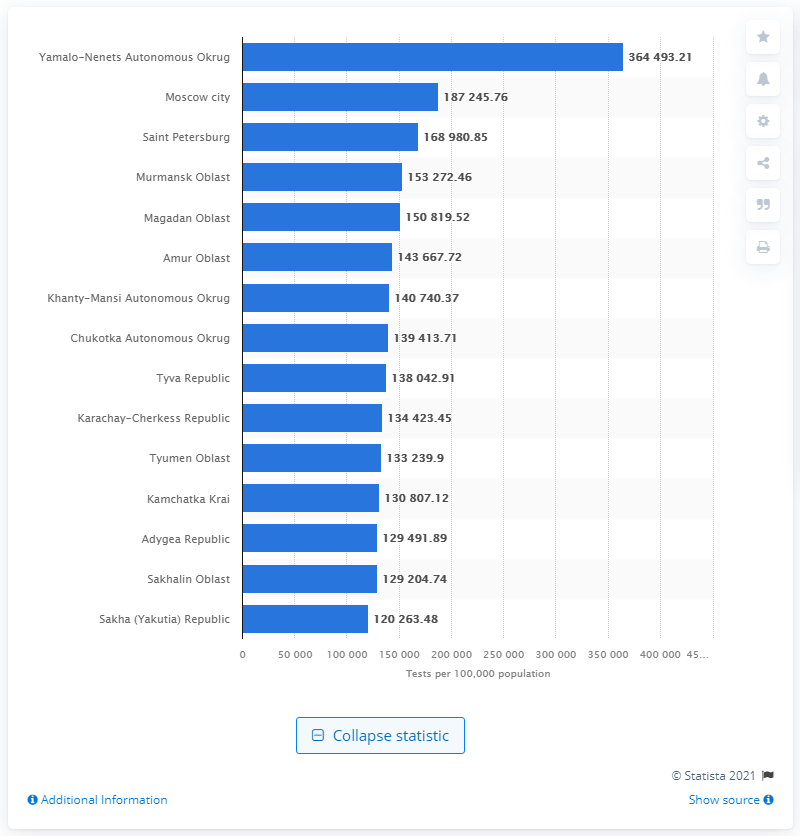Indicate a few pertinent items in this graphic. As of June 2, 2021, the population of the Yamalo-Nenets Autonomous Okrug was 364,493.21. 